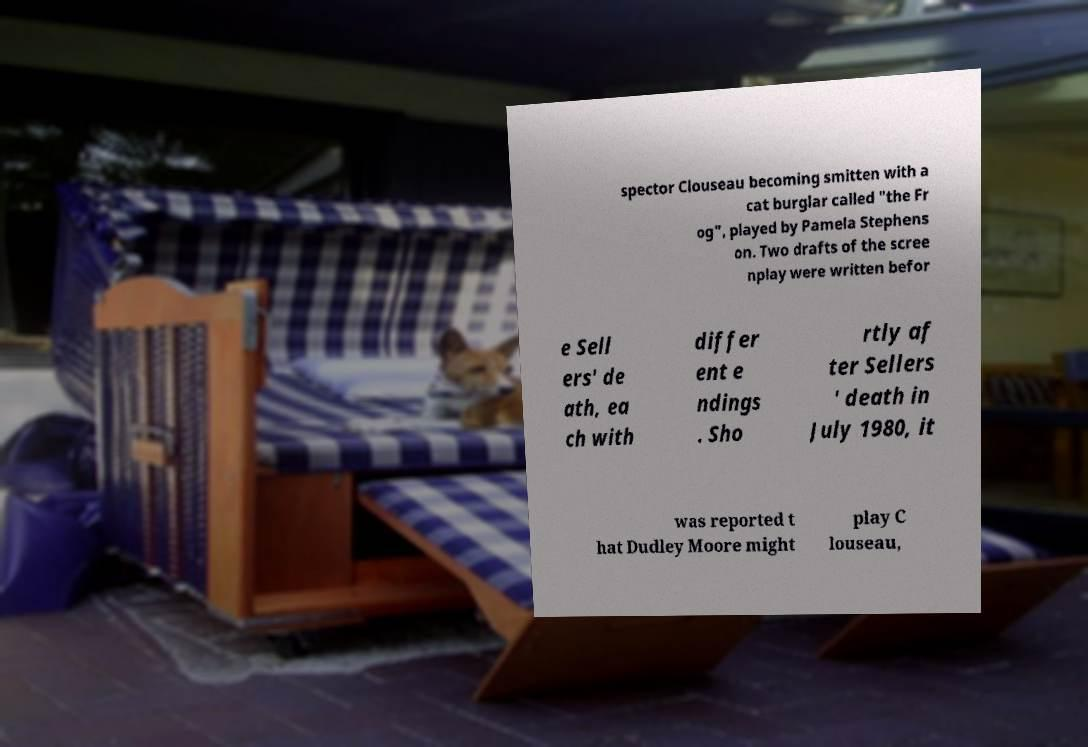What messages or text are displayed in this image? I need them in a readable, typed format. spector Clouseau becoming smitten with a cat burglar called "the Fr og", played by Pamela Stephens on. Two drafts of the scree nplay were written befor e Sell ers' de ath, ea ch with differ ent e ndings . Sho rtly af ter Sellers ' death in July 1980, it was reported t hat Dudley Moore might play C louseau, 